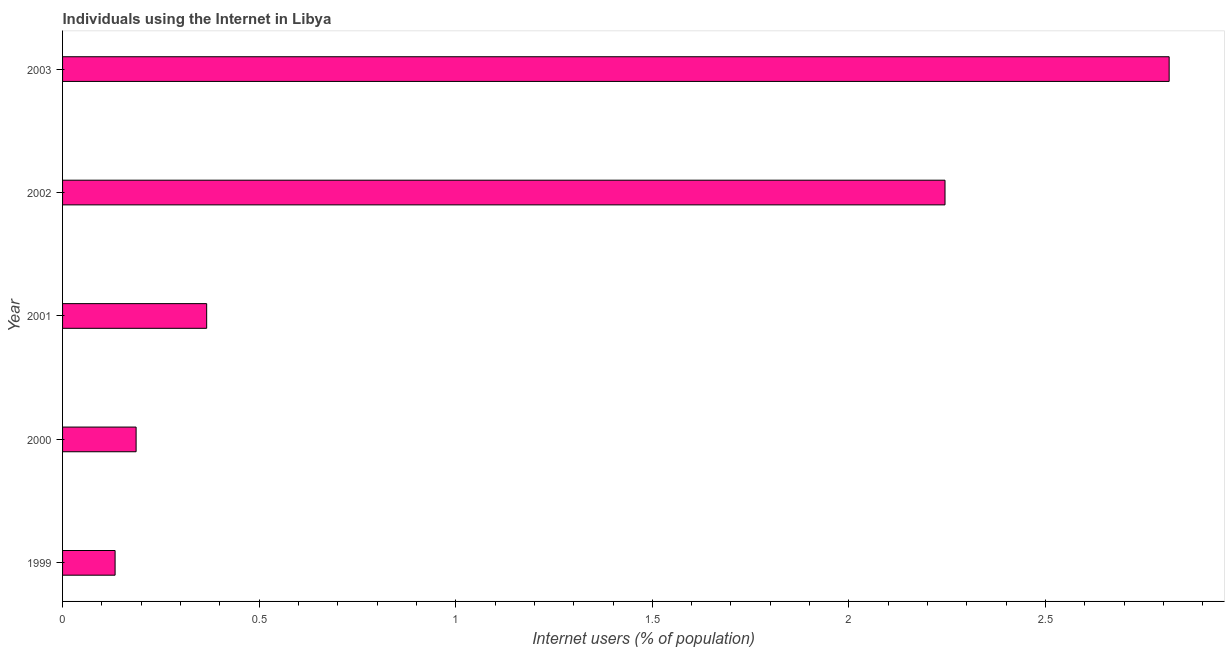Does the graph contain any zero values?
Ensure brevity in your answer.  No. What is the title of the graph?
Offer a terse response. Individuals using the Internet in Libya. What is the label or title of the X-axis?
Give a very brief answer. Internet users (% of population). What is the label or title of the Y-axis?
Your response must be concise. Year. What is the number of internet users in 2000?
Provide a succinct answer. 0.19. Across all years, what is the maximum number of internet users?
Give a very brief answer. 2.81. Across all years, what is the minimum number of internet users?
Your response must be concise. 0.13. In which year was the number of internet users minimum?
Offer a terse response. 1999. What is the sum of the number of internet users?
Ensure brevity in your answer.  5.75. What is the difference between the number of internet users in 1999 and 2002?
Offer a terse response. -2.11. What is the average number of internet users per year?
Ensure brevity in your answer.  1.15. What is the median number of internet users?
Keep it short and to the point. 0.37. In how many years, is the number of internet users greater than 2.8 %?
Offer a terse response. 1. What is the ratio of the number of internet users in 2001 to that in 2003?
Offer a terse response. 0.13. Is the number of internet users in 2000 less than that in 2002?
Your answer should be very brief. Yes. What is the difference between the highest and the second highest number of internet users?
Your answer should be very brief. 0.57. What is the difference between the highest and the lowest number of internet users?
Make the answer very short. 2.68. Are all the bars in the graph horizontal?
Keep it short and to the point. Yes. How many years are there in the graph?
Offer a very short reply. 5. What is the difference between two consecutive major ticks on the X-axis?
Ensure brevity in your answer.  0.5. Are the values on the major ticks of X-axis written in scientific E-notation?
Offer a very short reply. No. What is the Internet users (% of population) in 1999?
Keep it short and to the point. 0.13. What is the Internet users (% of population) in 2000?
Offer a very short reply. 0.19. What is the Internet users (% of population) in 2001?
Ensure brevity in your answer.  0.37. What is the Internet users (% of population) in 2002?
Give a very brief answer. 2.24. What is the Internet users (% of population) of 2003?
Your answer should be very brief. 2.81. What is the difference between the Internet users (% of population) in 1999 and 2000?
Keep it short and to the point. -0.05. What is the difference between the Internet users (% of population) in 1999 and 2001?
Offer a very short reply. -0.23. What is the difference between the Internet users (% of population) in 1999 and 2002?
Your answer should be compact. -2.11. What is the difference between the Internet users (% of population) in 1999 and 2003?
Your answer should be very brief. -2.68. What is the difference between the Internet users (% of population) in 2000 and 2001?
Offer a terse response. -0.18. What is the difference between the Internet users (% of population) in 2000 and 2002?
Give a very brief answer. -2.06. What is the difference between the Internet users (% of population) in 2000 and 2003?
Offer a terse response. -2.63. What is the difference between the Internet users (% of population) in 2001 and 2002?
Provide a succinct answer. -1.88. What is the difference between the Internet users (% of population) in 2001 and 2003?
Keep it short and to the point. -2.45. What is the difference between the Internet users (% of population) in 2002 and 2003?
Ensure brevity in your answer.  -0.57. What is the ratio of the Internet users (% of population) in 1999 to that in 2000?
Ensure brevity in your answer.  0.71. What is the ratio of the Internet users (% of population) in 1999 to that in 2001?
Your answer should be compact. 0.36. What is the ratio of the Internet users (% of population) in 1999 to that in 2003?
Offer a very short reply. 0.05. What is the ratio of the Internet users (% of population) in 2000 to that in 2001?
Your response must be concise. 0.51. What is the ratio of the Internet users (% of population) in 2000 to that in 2002?
Offer a terse response. 0.08. What is the ratio of the Internet users (% of population) in 2000 to that in 2003?
Give a very brief answer. 0.07. What is the ratio of the Internet users (% of population) in 2001 to that in 2002?
Your response must be concise. 0.16. What is the ratio of the Internet users (% of population) in 2001 to that in 2003?
Provide a short and direct response. 0.13. What is the ratio of the Internet users (% of population) in 2002 to that in 2003?
Provide a short and direct response. 0.8. 